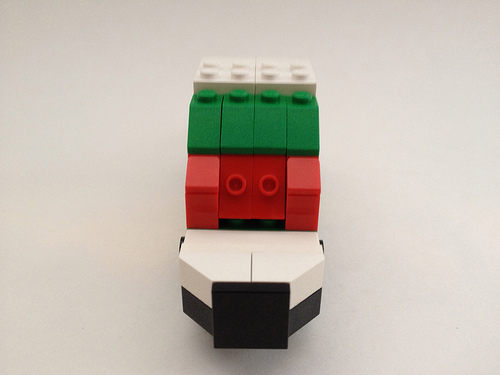<image>
Is there a toy in the air? No. The toy is not contained within the air. These objects have a different spatial relationship. 